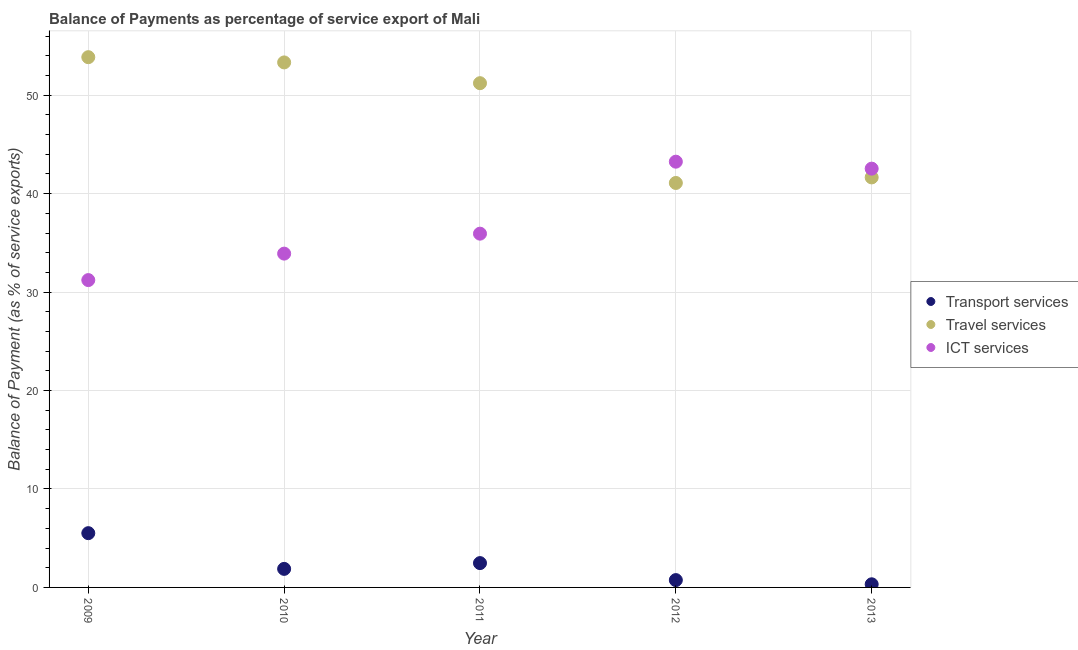How many different coloured dotlines are there?
Provide a short and direct response. 3. Is the number of dotlines equal to the number of legend labels?
Your response must be concise. Yes. What is the balance of payment of transport services in 2009?
Your answer should be compact. 5.51. Across all years, what is the maximum balance of payment of travel services?
Provide a short and direct response. 53.86. Across all years, what is the minimum balance of payment of travel services?
Your answer should be very brief. 41.09. What is the total balance of payment of travel services in the graph?
Provide a short and direct response. 241.15. What is the difference between the balance of payment of ict services in 2009 and that in 2011?
Your answer should be very brief. -4.72. What is the difference between the balance of payment of travel services in 2010 and the balance of payment of transport services in 2012?
Offer a very short reply. 52.59. What is the average balance of payment of travel services per year?
Keep it short and to the point. 48.23. In the year 2013, what is the difference between the balance of payment of travel services and balance of payment of ict services?
Ensure brevity in your answer.  -0.89. In how many years, is the balance of payment of transport services greater than 26 %?
Offer a very short reply. 0. What is the ratio of the balance of payment of ict services in 2009 to that in 2012?
Offer a very short reply. 0.72. Is the balance of payment of transport services in 2010 less than that in 2012?
Your answer should be very brief. No. What is the difference between the highest and the second highest balance of payment of ict services?
Your answer should be very brief. 0.71. What is the difference between the highest and the lowest balance of payment of ict services?
Make the answer very short. 12.03. In how many years, is the balance of payment of travel services greater than the average balance of payment of travel services taken over all years?
Keep it short and to the point. 3. Does the balance of payment of ict services monotonically increase over the years?
Give a very brief answer. No. How many dotlines are there?
Make the answer very short. 3. What is the difference between two consecutive major ticks on the Y-axis?
Keep it short and to the point. 10. How are the legend labels stacked?
Ensure brevity in your answer.  Vertical. What is the title of the graph?
Make the answer very short. Balance of Payments as percentage of service export of Mali. What is the label or title of the Y-axis?
Give a very brief answer. Balance of Payment (as % of service exports). What is the Balance of Payment (as % of service exports) of Transport services in 2009?
Ensure brevity in your answer.  5.51. What is the Balance of Payment (as % of service exports) of Travel services in 2009?
Give a very brief answer. 53.86. What is the Balance of Payment (as % of service exports) in ICT services in 2009?
Give a very brief answer. 31.22. What is the Balance of Payment (as % of service exports) of Transport services in 2010?
Give a very brief answer. 1.88. What is the Balance of Payment (as % of service exports) in Travel services in 2010?
Your answer should be compact. 53.33. What is the Balance of Payment (as % of service exports) in ICT services in 2010?
Provide a short and direct response. 33.91. What is the Balance of Payment (as % of service exports) in Transport services in 2011?
Ensure brevity in your answer.  2.47. What is the Balance of Payment (as % of service exports) in Travel services in 2011?
Offer a very short reply. 51.22. What is the Balance of Payment (as % of service exports) of ICT services in 2011?
Make the answer very short. 35.94. What is the Balance of Payment (as % of service exports) in Transport services in 2012?
Your response must be concise. 0.74. What is the Balance of Payment (as % of service exports) in Travel services in 2012?
Your answer should be compact. 41.09. What is the Balance of Payment (as % of service exports) of ICT services in 2012?
Your response must be concise. 43.25. What is the Balance of Payment (as % of service exports) in Transport services in 2013?
Offer a very short reply. 0.32. What is the Balance of Payment (as % of service exports) in Travel services in 2013?
Provide a short and direct response. 41.65. What is the Balance of Payment (as % of service exports) in ICT services in 2013?
Your answer should be compact. 42.54. Across all years, what is the maximum Balance of Payment (as % of service exports) of Transport services?
Ensure brevity in your answer.  5.51. Across all years, what is the maximum Balance of Payment (as % of service exports) of Travel services?
Provide a succinct answer. 53.86. Across all years, what is the maximum Balance of Payment (as % of service exports) of ICT services?
Keep it short and to the point. 43.25. Across all years, what is the minimum Balance of Payment (as % of service exports) of Transport services?
Make the answer very short. 0.32. Across all years, what is the minimum Balance of Payment (as % of service exports) in Travel services?
Provide a succinct answer. 41.09. Across all years, what is the minimum Balance of Payment (as % of service exports) in ICT services?
Offer a terse response. 31.22. What is the total Balance of Payment (as % of service exports) of Transport services in the graph?
Make the answer very short. 10.93. What is the total Balance of Payment (as % of service exports) in Travel services in the graph?
Ensure brevity in your answer.  241.15. What is the total Balance of Payment (as % of service exports) of ICT services in the graph?
Your answer should be compact. 186.85. What is the difference between the Balance of Payment (as % of service exports) of Transport services in 2009 and that in 2010?
Give a very brief answer. 3.63. What is the difference between the Balance of Payment (as % of service exports) in Travel services in 2009 and that in 2010?
Offer a terse response. 0.53. What is the difference between the Balance of Payment (as % of service exports) of ICT services in 2009 and that in 2010?
Your answer should be compact. -2.69. What is the difference between the Balance of Payment (as % of service exports) in Transport services in 2009 and that in 2011?
Your answer should be compact. 3.04. What is the difference between the Balance of Payment (as % of service exports) in Travel services in 2009 and that in 2011?
Offer a terse response. 2.64. What is the difference between the Balance of Payment (as % of service exports) of ICT services in 2009 and that in 2011?
Provide a short and direct response. -4.72. What is the difference between the Balance of Payment (as % of service exports) of Transport services in 2009 and that in 2012?
Provide a succinct answer. 4.77. What is the difference between the Balance of Payment (as % of service exports) in Travel services in 2009 and that in 2012?
Give a very brief answer. 12.78. What is the difference between the Balance of Payment (as % of service exports) in ICT services in 2009 and that in 2012?
Your response must be concise. -12.03. What is the difference between the Balance of Payment (as % of service exports) in Transport services in 2009 and that in 2013?
Keep it short and to the point. 5.19. What is the difference between the Balance of Payment (as % of service exports) of Travel services in 2009 and that in 2013?
Keep it short and to the point. 12.21. What is the difference between the Balance of Payment (as % of service exports) in ICT services in 2009 and that in 2013?
Provide a short and direct response. -11.32. What is the difference between the Balance of Payment (as % of service exports) of Transport services in 2010 and that in 2011?
Provide a succinct answer. -0.59. What is the difference between the Balance of Payment (as % of service exports) in Travel services in 2010 and that in 2011?
Provide a short and direct response. 2.11. What is the difference between the Balance of Payment (as % of service exports) in ICT services in 2010 and that in 2011?
Your answer should be compact. -2.03. What is the difference between the Balance of Payment (as % of service exports) in Transport services in 2010 and that in 2012?
Give a very brief answer. 1.14. What is the difference between the Balance of Payment (as % of service exports) in Travel services in 2010 and that in 2012?
Ensure brevity in your answer.  12.25. What is the difference between the Balance of Payment (as % of service exports) in ICT services in 2010 and that in 2012?
Offer a very short reply. -9.34. What is the difference between the Balance of Payment (as % of service exports) of Transport services in 2010 and that in 2013?
Keep it short and to the point. 1.57. What is the difference between the Balance of Payment (as % of service exports) in Travel services in 2010 and that in 2013?
Your answer should be very brief. 11.68. What is the difference between the Balance of Payment (as % of service exports) of ICT services in 2010 and that in 2013?
Give a very brief answer. -8.63. What is the difference between the Balance of Payment (as % of service exports) in Transport services in 2011 and that in 2012?
Provide a succinct answer. 1.73. What is the difference between the Balance of Payment (as % of service exports) in Travel services in 2011 and that in 2012?
Your response must be concise. 10.14. What is the difference between the Balance of Payment (as % of service exports) in ICT services in 2011 and that in 2012?
Keep it short and to the point. -7.31. What is the difference between the Balance of Payment (as % of service exports) of Transport services in 2011 and that in 2013?
Offer a very short reply. 2.15. What is the difference between the Balance of Payment (as % of service exports) of Travel services in 2011 and that in 2013?
Your response must be concise. 9.57. What is the difference between the Balance of Payment (as % of service exports) of ICT services in 2011 and that in 2013?
Make the answer very short. -6.6. What is the difference between the Balance of Payment (as % of service exports) of Transport services in 2012 and that in 2013?
Your answer should be compact. 0.43. What is the difference between the Balance of Payment (as % of service exports) in Travel services in 2012 and that in 2013?
Keep it short and to the point. -0.56. What is the difference between the Balance of Payment (as % of service exports) of ICT services in 2012 and that in 2013?
Offer a terse response. 0.71. What is the difference between the Balance of Payment (as % of service exports) in Transport services in 2009 and the Balance of Payment (as % of service exports) in Travel services in 2010?
Your answer should be compact. -47.82. What is the difference between the Balance of Payment (as % of service exports) in Transport services in 2009 and the Balance of Payment (as % of service exports) in ICT services in 2010?
Give a very brief answer. -28.4. What is the difference between the Balance of Payment (as % of service exports) in Travel services in 2009 and the Balance of Payment (as % of service exports) in ICT services in 2010?
Make the answer very short. 19.95. What is the difference between the Balance of Payment (as % of service exports) in Transport services in 2009 and the Balance of Payment (as % of service exports) in Travel services in 2011?
Your response must be concise. -45.71. What is the difference between the Balance of Payment (as % of service exports) of Transport services in 2009 and the Balance of Payment (as % of service exports) of ICT services in 2011?
Ensure brevity in your answer.  -30.42. What is the difference between the Balance of Payment (as % of service exports) in Travel services in 2009 and the Balance of Payment (as % of service exports) in ICT services in 2011?
Make the answer very short. 17.93. What is the difference between the Balance of Payment (as % of service exports) of Transport services in 2009 and the Balance of Payment (as % of service exports) of Travel services in 2012?
Your answer should be very brief. -35.57. What is the difference between the Balance of Payment (as % of service exports) in Transport services in 2009 and the Balance of Payment (as % of service exports) in ICT services in 2012?
Provide a succinct answer. -37.74. What is the difference between the Balance of Payment (as % of service exports) of Travel services in 2009 and the Balance of Payment (as % of service exports) of ICT services in 2012?
Offer a terse response. 10.62. What is the difference between the Balance of Payment (as % of service exports) of Transport services in 2009 and the Balance of Payment (as % of service exports) of Travel services in 2013?
Keep it short and to the point. -36.14. What is the difference between the Balance of Payment (as % of service exports) of Transport services in 2009 and the Balance of Payment (as % of service exports) of ICT services in 2013?
Offer a terse response. -37.03. What is the difference between the Balance of Payment (as % of service exports) of Travel services in 2009 and the Balance of Payment (as % of service exports) of ICT services in 2013?
Your answer should be very brief. 11.32. What is the difference between the Balance of Payment (as % of service exports) of Transport services in 2010 and the Balance of Payment (as % of service exports) of Travel services in 2011?
Offer a very short reply. -49.34. What is the difference between the Balance of Payment (as % of service exports) in Transport services in 2010 and the Balance of Payment (as % of service exports) in ICT services in 2011?
Offer a very short reply. -34.05. What is the difference between the Balance of Payment (as % of service exports) in Travel services in 2010 and the Balance of Payment (as % of service exports) in ICT services in 2011?
Provide a short and direct response. 17.4. What is the difference between the Balance of Payment (as % of service exports) of Transport services in 2010 and the Balance of Payment (as % of service exports) of Travel services in 2012?
Give a very brief answer. -39.2. What is the difference between the Balance of Payment (as % of service exports) of Transport services in 2010 and the Balance of Payment (as % of service exports) of ICT services in 2012?
Ensure brevity in your answer.  -41.36. What is the difference between the Balance of Payment (as % of service exports) in Travel services in 2010 and the Balance of Payment (as % of service exports) in ICT services in 2012?
Provide a succinct answer. 10.08. What is the difference between the Balance of Payment (as % of service exports) in Transport services in 2010 and the Balance of Payment (as % of service exports) in Travel services in 2013?
Provide a short and direct response. -39.77. What is the difference between the Balance of Payment (as % of service exports) of Transport services in 2010 and the Balance of Payment (as % of service exports) of ICT services in 2013?
Offer a very short reply. -40.66. What is the difference between the Balance of Payment (as % of service exports) of Travel services in 2010 and the Balance of Payment (as % of service exports) of ICT services in 2013?
Provide a short and direct response. 10.79. What is the difference between the Balance of Payment (as % of service exports) of Transport services in 2011 and the Balance of Payment (as % of service exports) of Travel services in 2012?
Keep it short and to the point. -38.61. What is the difference between the Balance of Payment (as % of service exports) of Transport services in 2011 and the Balance of Payment (as % of service exports) of ICT services in 2012?
Provide a succinct answer. -40.78. What is the difference between the Balance of Payment (as % of service exports) of Travel services in 2011 and the Balance of Payment (as % of service exports) of ICT services in 2012?
Your response must be concise. 7.97. What is the difference between the Balance of Payment (as % of service exports) in Transport services in 2011 and the Balance of Payment (as % of service exports) in Travel services in 2013?
Ensure brevity in your answer.  -39.18. What is the difference between the Balance of Payment (as % of service exports) of Transport services in 2011 and the Balance of Payment (as % of service exports) of ICT services in 2013?
Ensure brevity in your answer.  -40.07. What is the difference between the Balance of Payment (as % of service exports) of Travel services in 2011 and the Balance of Payment (as % of service exports) of ICT services in 2013?
Make the answer very short. 8.68. What is the difference between the Balance of Payment (as % of service exports) of Transport services in 2012 and the Balance of Payment (as % of service exports) of Travel services in 2013?
Ensure brevity in your answer.  -40.91. What is the difference between the Balance of Payment (as % of service exports) of Transport services in 2012 and the Balance of Payment (as % of service exports) of ICT services in 2013?
Offer a very short reply. -41.8. What is the difference between the Balance of Payment (as % of service exports) in Travel services in 2012 and the Balance of Payment (as % of service exports) in ICT services in 2013?
Your answer should be very brief. -1.45. What is the average Balance of Payment (as % of service exports) of Transport services per year?
Make the answer very short. 2.19. What is the average Balance of Payment (as % of service exports) of Travel services per year?
Your answer should be compact. 48.23. What is the average Balance of Payment (as % of service exports) in ICT services per year?
Your answer should be very brief. 37.37. In the year 2009, what is the difference between the Balance of Payment (as % of service exports) in Transport services and Balance of Payment (as % of service exports) in Travel services?
Offer a very short reply. -48.35. In the year 2009, what is the difference between the Balance of Payment (as % of service exports) in Transport services and Balance of Payment (as % of service exports) in ICT services?
Provide a short and direct response. -25.71. In the year 2009, what is the difference between the Balance of Payment (as % of service exports) in Travel services and Balance of Payment (as % of service exports) in ICT services?
Keep it short and to the point. 22.64. In the year 2010, what is the difference between the Balance of Payment (as % of service exports) in Transport services and Balance of Payment (as % of service exports) in Travel services?
Provide a short and direct response. -51.45. In the year 2010, what is the difference between the Balance of Payment (as % of service exports) in Transport services and Balance of Payment (as % of service exports) in ICT services?
Offer a very short reply. -32.02. In the year 2010, what is the difference between the Balance of Payment (as % of service exports) of Travel services and Balance of Payment (as % of service exports) of ICT services?
Keep it short and to the point. 19.42. In the year 2011, what is the difference between the Balance of Payment (as % of service exports) in Transport services and Balance of Payment (as % of service exports) in Travel services?
Offer a terse response. -48.75. In the year 2011, what is the difference between the Balance of Payment (as % of service exports) in Transport services and Balance of Payment (as % of service exports) in ICT services?
Give a very brief answer. -33.46. In the year 2011, what is the difference between the Balance of Payment (as % of service exports) in Travel services and Balance of Payment (as % of service exports) in ICT services?
Make the answer very short. 15.29. In the year 2012, what is the difference between the Balance of Payment (as % of service exports) in Transport services and Balance of Payment (as % of service exports) in Travel services?
Give a very brief answer. -40.34. In the year 2012, what is the difference between the Balance of Payment (as % of service exports) in Transport services and Balance of Payment (as % of service exports) in ICT services?
Offer a very short reply. -42.5. In the year 2012, what is the difference between the Balance of Payment (as % of service exports) in Travel services and Balance of Payment (as % of service exports) in ICT services?
Provide a succinct answer. -2.16. In the year 2013, what is the difference between the Balance of Payment (as % of service exports) of Transport services and Balance of Payment (as % of service exports) of Travel services?
Provide a short and direct response. -41.33. In the year 2013, what is the difference between the Balance of Payment (as % of service exports) in Transport services and Balance of Payment (as % of service exports) in ICT services?
Your response must be concise. -42.22. In the year 2013, what is the difference between the Balance of Payment (as % of service exports) in Travel services and Balance of Payment (as % of service exports) in ICT services?
Make the answer very short. -0.89. What is the ratio of the Balance of Payment (as % of service exports) in Transport services in 2009 to that in 2010?
Keep it short and to the point. 2.93. What is the ratio of the Balance of Payment (as % of service exports) in ICT services in 2009 to that in 2010?
Your answer should be very brief. 0.92. What is the ratio of the Balance of Payment (as % of service exports) of Transport services in 2009 to that in 2011?
Offer a very short reply. 2.23. What is the ratio of the Balance of Payment (as % of service exports) in Travel services in 2009 to that in 2011?
Your response must be concise. 1.05. What is the ratio of the Balance of Payment (as % of service exports) in ICT services in 2009 to that in 2011?
Your response must be concise. 0.87. What is the ratio of the Balance of Payment (as % of service exports) of Transport services in 2009 to that in 2012?
Your answer should be compact. 7.4. What is the ratio of the Balance of Payment (as % of service exports) of Travel services in 2009 to that in 2012?
Your answer should be compact. 1.31. What is the ratio of the Balance of Payment (as % of service exports) in ICT services in 2009 to that in 2012?
Ensure brevity in your answer.  0.72. What is the ratio of the Balance of Payment (as % of service exports) in Transport services in 2009 to that in 2013?
Provide a succinct answer. 17.33. What is the ratio of the Balance of Payment (as % of service exports) in Travel services in 2009 to that in 2013?
Offer a very short reply. 1.29. What is the ratio of the Balance of Payment (as % of service exports) in ICT services in 2009 to that in 2013?
Make the answer very short. 0.73. What is the ratio of the Balance of Payment (as % of service exports) of Transport services in 2010 to that in 2011?
Keep it short and to the point. 0.76. What is the ratio of the Balance of Payment (as % of service exports) in Travel services in 2010 to that in 2011?
Your answer should be compact. 1.04. What is the ratio of the Balance of Payment (as % of service exports) in ICT services in 2010 to that in 2011?
Your answer should be very brief. 0.94. What is the ratio of the Balance of Payment (as % of service exports) of Transport services in 2010 to that in 2012?
Keep it short and to the point. 2.53. What is the ratio of the Balance of Payment (as % of service exports) of Travel services in 2010 to that in 2012?
Your answer should be compact. 1.3. What is the ratio of the Balance of Payment (as % of service exports) in ICT services in 2010 to that in 2012?
Your answer should be very brief. 0.78. What is the ratio of the Balance of Payment (as % of service exports) of Transport services in 2010 to that in 2013?
Offer a very short reply. 5.92. What is the ratio of the Balance of Payment (as % of service exports) of Travel services in 2010 to that in 2013?
Make the answer very short. 1.28. What is the ratio of the Balance of Payment (as % of service exports) in ICT services in 2010 to that in 2013?
Your answer should be very brief. 0.8. What is the ratio of the Balance of Payment (as % of service exports) of Transport services in 2011 to that in 2012?
Provide a succinct answer. 3.32. What is the ratio of the Balance of Payment (as % of service exports) in Travel services in 2011 to that in 2012?
Offer a terse response. 1.25. What is the ratio of the Balance of Payment (as % of service exports) of ICT services in 2011 to that in 2012?
Offer a very short reply. 0.83. What is the ratio of the Balance of Payment (as % of service exports) in Transport services in 2011 to that in 2013?
Keep it short and to the point. 7.77. What is the ratio of the Balance of Payment (as % of service exports) of Travel services in 2011 to that in 2013?
Your answer should be compact. 1.23. What is the ratio of the Balance of Payment (as % of service exports) of ICT services in 2011 to that in 2013?
Give a very brief answer. 0.84. What is the ratio of the Balance of Payment (as % of service exports) in Transport services in 2012 to that in 2013?
Provide a short and direct response. 2.34. What is the ratio of the Balance of Payment (as % of service exports) in Travel services in 2012 to that in 2013?
Make the answer very short. 0.99. What is the ratio of the Balance of Payment (as % of service exports) in ICT services in 2012 to that in 2013?
Make the answer very short. 1.02. What is the difference between the highest and the second highest Balance of Payment (as % of service exports) in Transport services?
Provide a succinct answer. 3.04. What is the difference between the highest and the second highest Balance of Payment (as % of service exports) in Travel services?
Provide a succinct answer. 0.53. What is the difference between the highest and the second highest Balance of Payment (as % of service exports) of ICT services?
Ensure brevity in your answer.  0.71. What is the difference between the highest and the lowest Balance of Payment (as % of service exports) in Transport services?
Your response must be concise. 5.19. What is the difference between the highest and the lowest Balance of Payment (as % of service exports) in Travel services?
Give a very brief answer. 12.78. What is the difference between the highest and the lowest Balance of Payment (as % of service exports) in ICT services?
Offer a terse response. 12.03. 